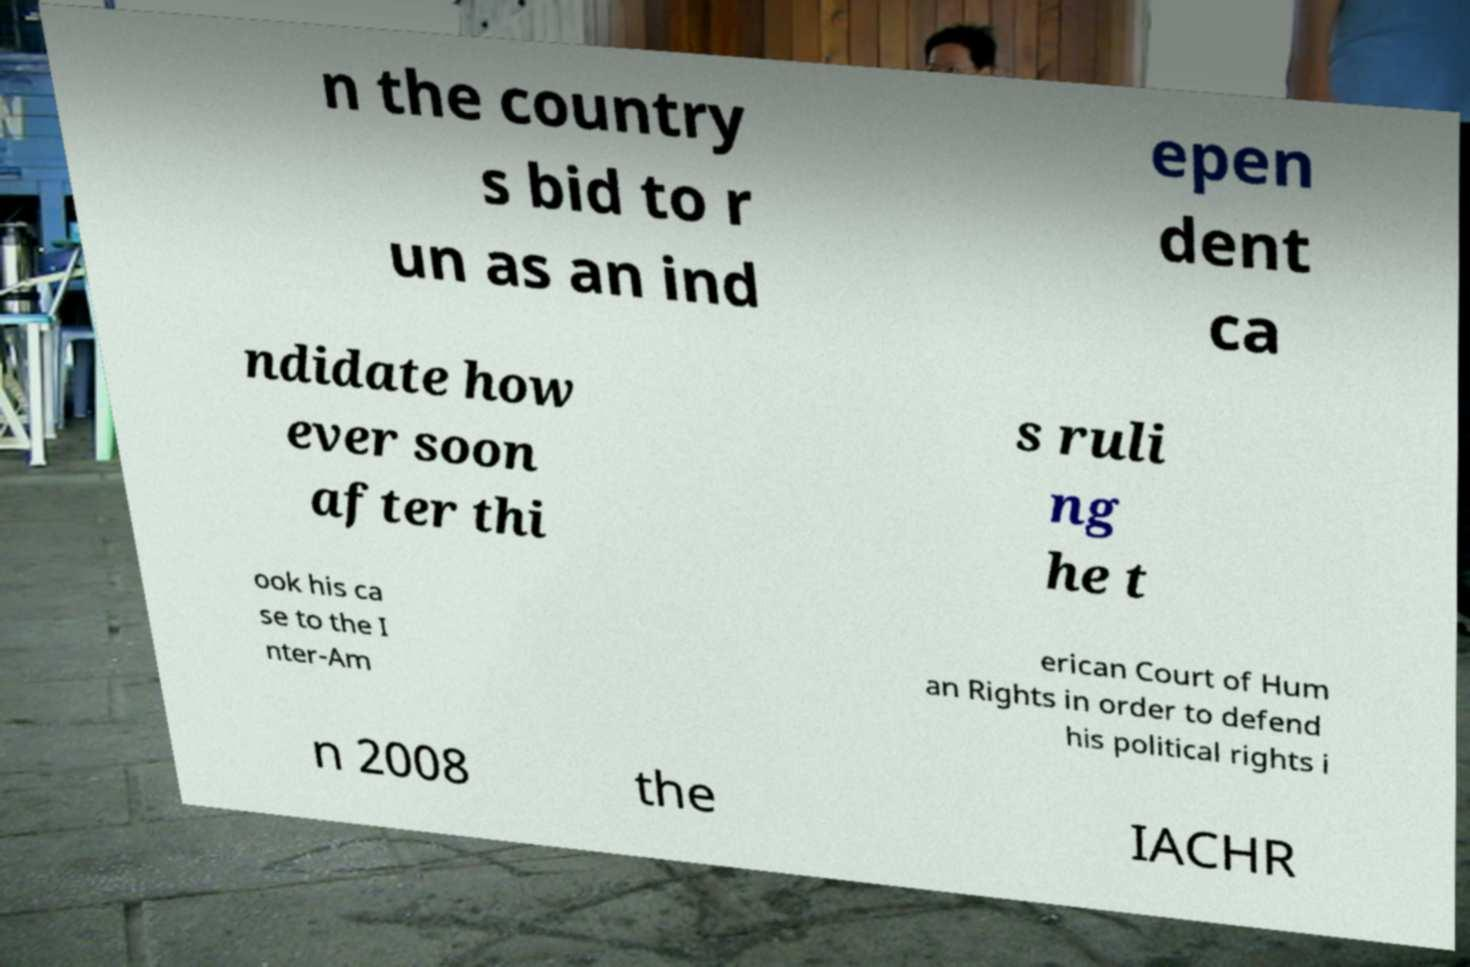Can you read and provide the text displayed in the image?This photo seems to have some interesting text. Can you extract and type it out for me? n the country s bid to r un as an ind epen dent ca ndidate how ever soon after thi s ruli ng he t ook his ca se to the I nter-Am erican Court of Hum an Rights in order to defend his political rights i n 2008 the IACHR 